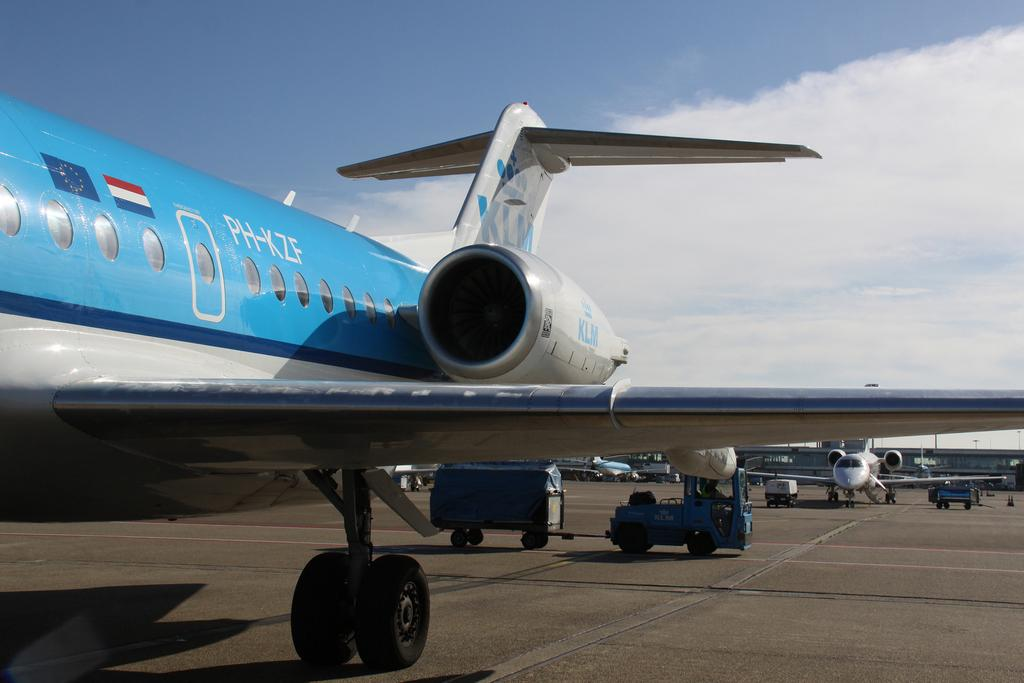<image>
Present a compact description of the photo's key features. White letter of PH-KZE are visible on the side of the plane. 